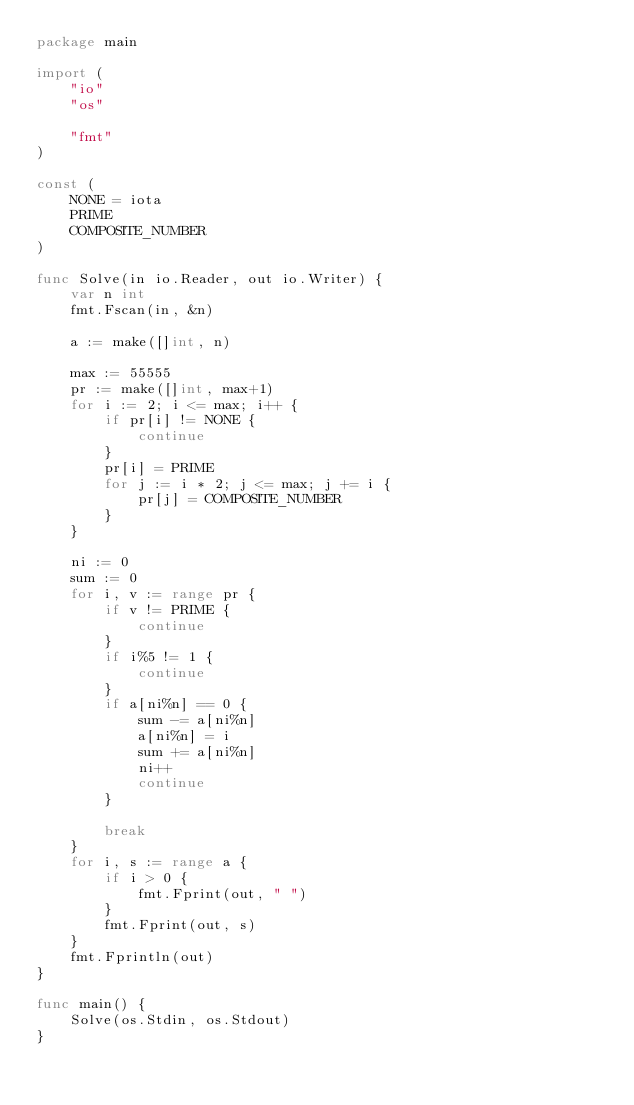<code> <loc_0><loc_0><loc_500><loc_500><_Go_>package main

import (
	"io"
	"os"

	"fmt"
)

const (
	NONE = iota
	PRIME
	COMPOSITE_NUMBER
)

func Solve(in io.Reader, out io.Writer) {
	var n int
	fmt.Fscan(in, &n)

	a := make([]int, n)

	max := 55555
	pr := make([]int, max+1)
	for i := 2; i <= max; i++ {
		if pr[i] != NONE {
			continue
		}
		pr[i] = PRIME
		for j := i * 2; j <= max; j += i {
			pr[j] = COMPOSITE_NUMBER
		}
	}

	ni := 0
	sum := 0
	for i, v := range pr {
		if v != PRIME {
			continue
		}
		if i%5 != 1 {
			continue
		}
		if a[ni%n] == 0 {
			sum -= a[ni%n]
			a[ni%n] = i
			sum += a[ni%n]
			ni++
			continue
		}

		break
	}
	for i, s := range a {
		if i > 0 {
			fmt.Fprint(out, " ")
		}
		fmt.Fprint(out, s)
	}
	fmt.Fprintln(out)
}

func main() {
	Solve(os.Stdin, os.Stdout)
}
</code> 